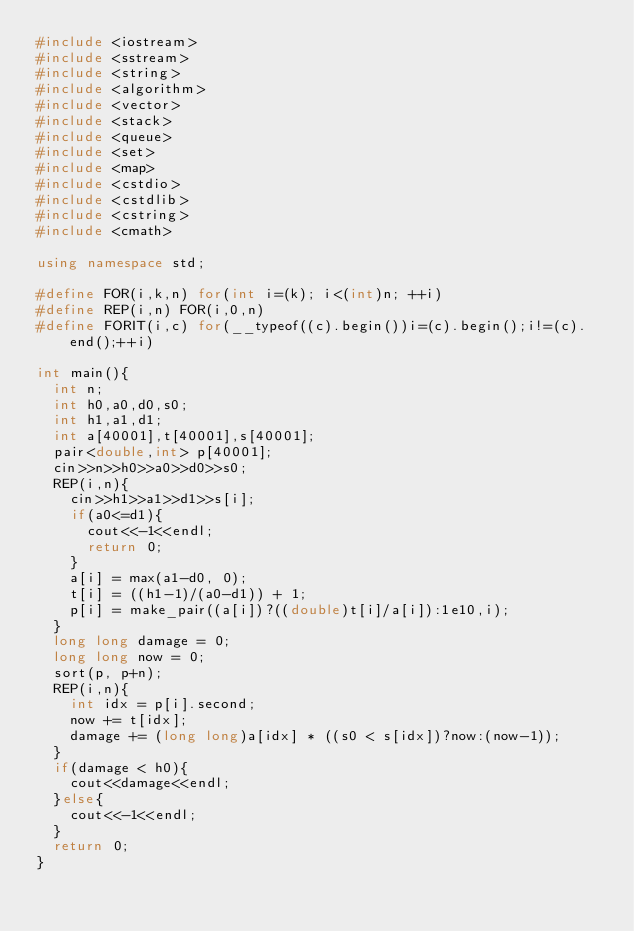Convert code to text. <code><loc_0><loc_0><loc_500><loc_500><_C++_>#include <iostream>
#include <sstream>
#include <string>
#include <algorithm>
#include <vector>
#include <stack>
#include <queue>
#include <set>
#include <map>
#include <cstdio>
#include <cstdlib>
#include <cstring>
#include <cmath>

using namespace std;

#define FOR(i,k,n) for(int i=(k); i<(int)n; ++i)
#define REP(i,n) FOR(i,0,n)
#define FORIT(i,c) for(__typeof((c).begin())i=(c).begin();i!=(c).end();++i)

int main(){
  int n;
  int h0,a0,d0,s0;
  int h1,a1,d1;
  int a[40001],t[40001],s[40001];
  pair<double,int> p[40001];
  cin>>n>>h0>>a0>>d0>>s0;
  REP(i,n){
    cin>>h1>>a1>>d1>>s[i];
    if(a0<=d1){
      cout<<-1<<endl;
      return 0;
    }
    a[i] = max(a1-d0, 0);
    t[i] = ((h1-1)/(a0-d1)) + 1;
    p[i] = make_pair((a[i])?((double)t[i]/a[i]):1e10,i);
  }
  long long damage = 0;
  long long now = 0;
  sort(p, p+n);
  REP(i,n){
    int idx = p[i].second;
    now += t[idx];
    damage += (long long)a[idx] * ((s0 < s[idx])?now:(now-1));
  }
  if(damage < h0){
    cout<<damage<<endl;
  }else{
    cout<<-1<<endl;
  }
  return 0;
}</code> 